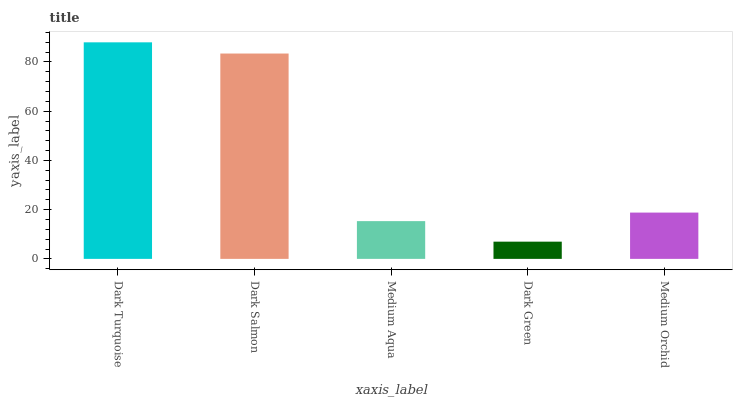Is Dark Green the minimum?
Answer yes or no. Yes. Is Dark Turquoise the maximum?
Answer yes or no. Yes. Is Dark Salmon the minimum?
Answer yes or no. No. Is Dark Salmon the maximum?
Answer yes or no. No. Is Dark Turquoise greater than Dark Salmon?
Answer yes or no. Yes. Is Dark Salmon less than Dark Turquoise?
Answer yes or no. Yes. Is Dark Salmon greater than Dark Turquoise?
Answer yes or no. No. Is Dark Turquoise less than Dark Salmon?
Answer yes or no. No. Is Medium Orchid the high median?
Answer yes or no. Yes. Is Medium Orchid the low median?
Answer yes or no. Yes. Is Medium Aqua the high median?
Answer yes or no. No. Is Dark Salmon the low median?
Answer yes or no. No. 